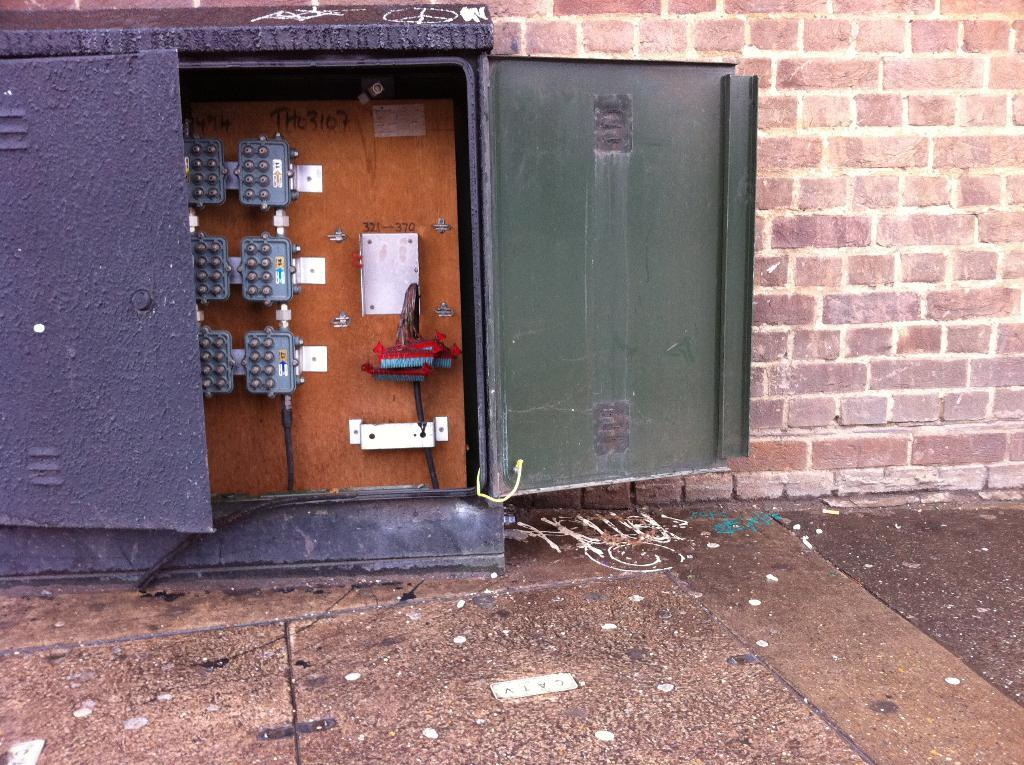What is the main object in the image? There is an electric board in the image. Where is the electric board located? The electric board is attached to a brick wall. Can you tell me what the electric board is talking about in the image? Electric boards do not talk; they are inanimate objects that display information or control electrical devices. 